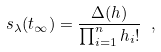Convert formula to latex. <formula><loc_0><loc_0><loc_500><loc_500>s _ { \lambda } ( { t } _ { \infty } ) = \frac { \Delta ( h ) } { \prod ^ { n } _ { i = 1 } h _ { i } ! } \ ,</formula> 